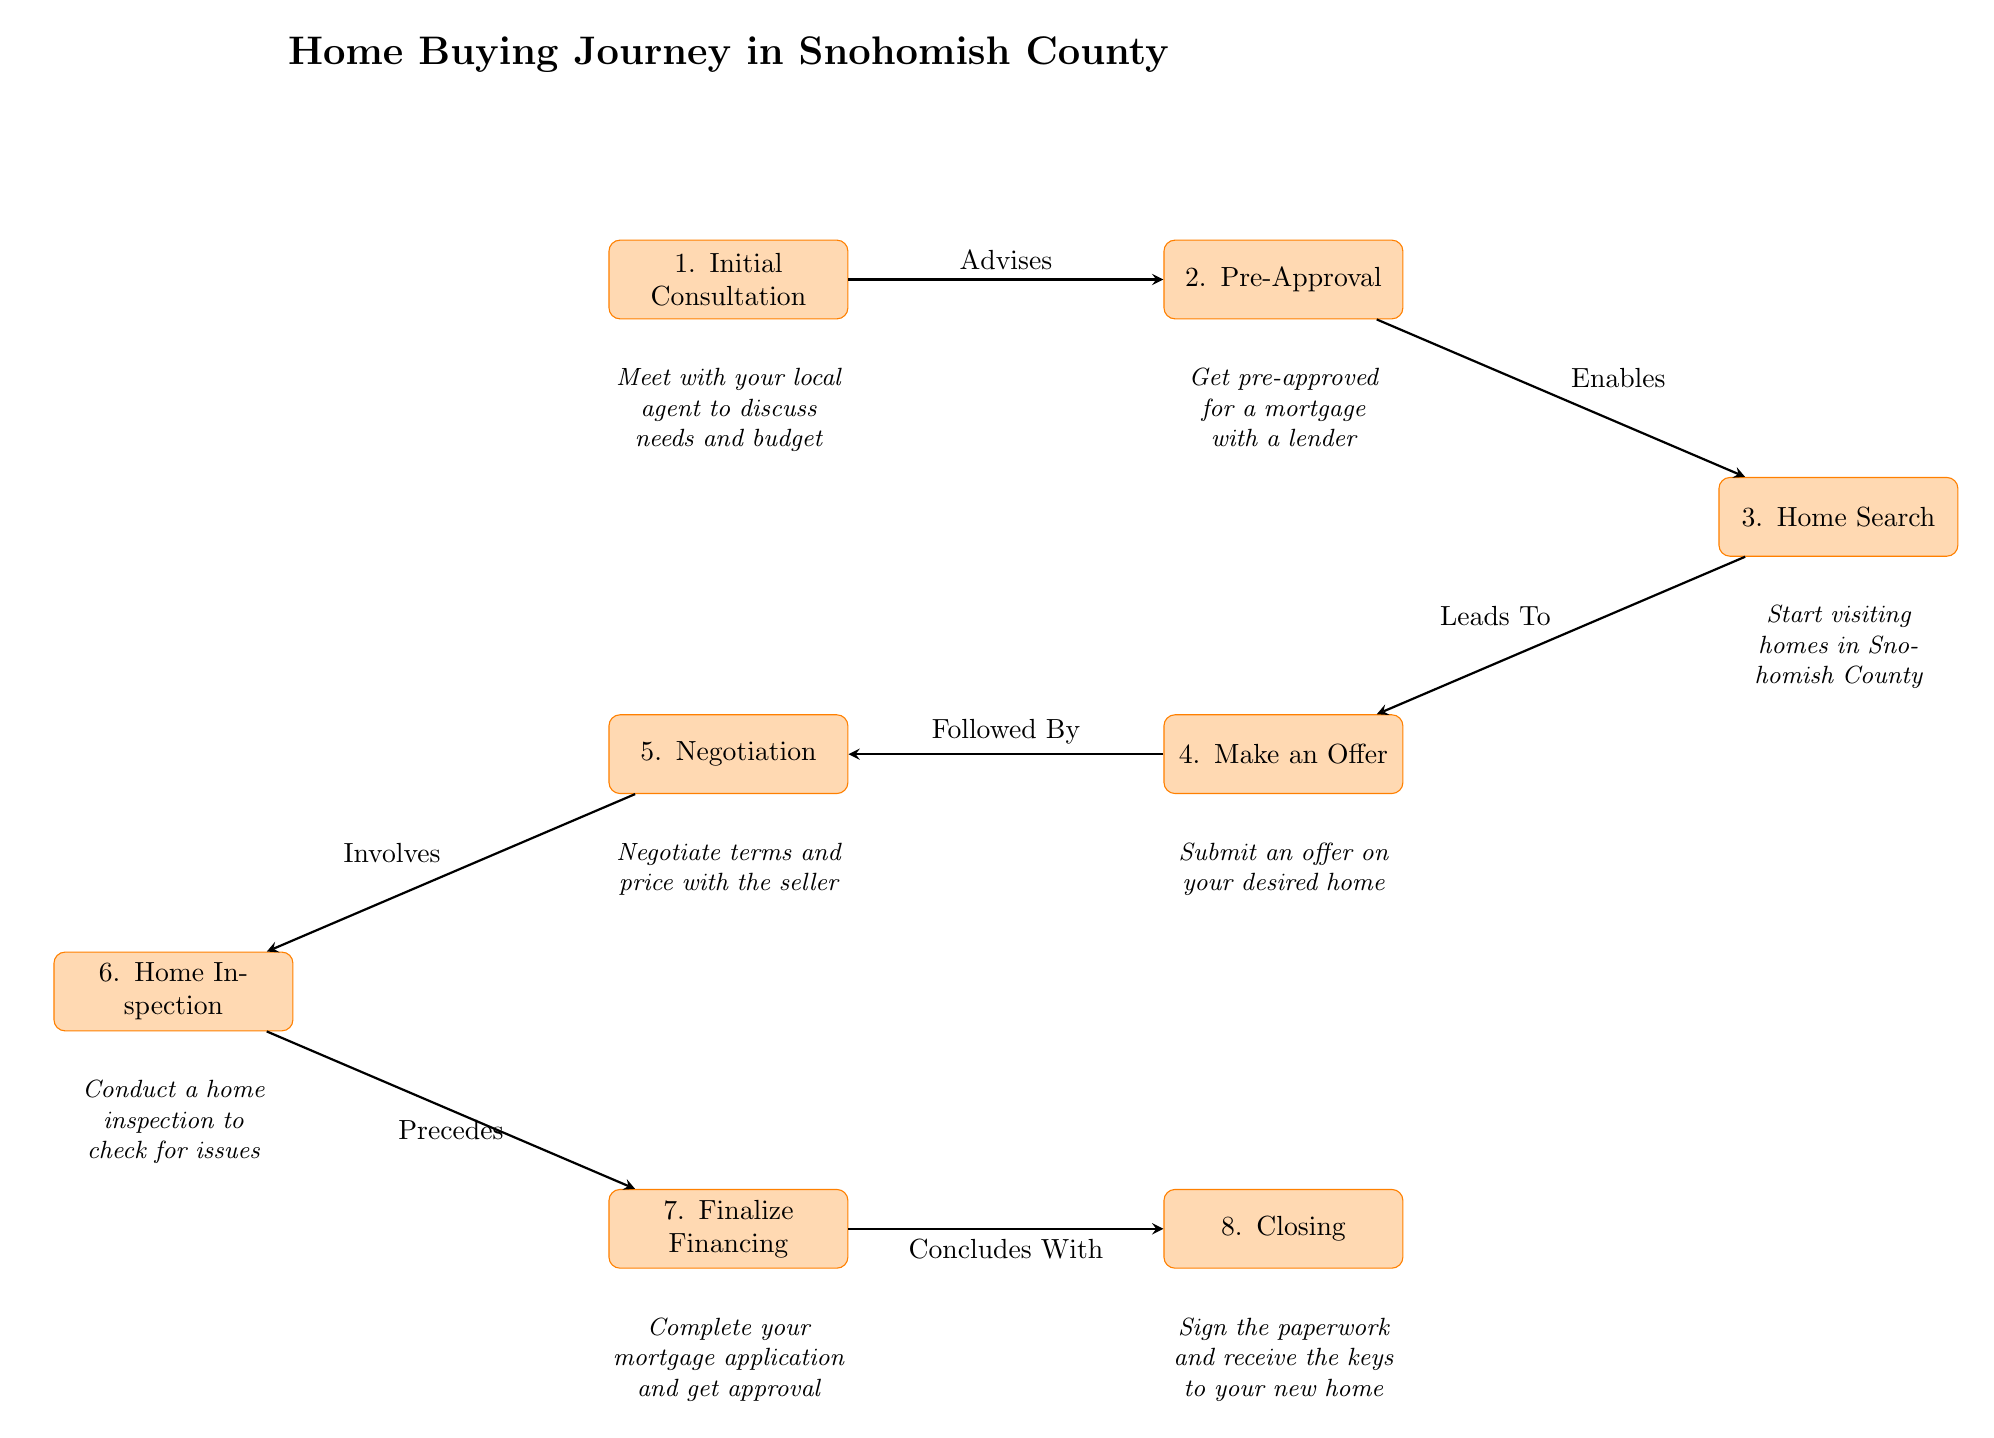What is the first step in the home buying journey? The first step in the journey is represented by the node labeled "1. Initial Consultation." It is the starting point before any other actions take place.
Answer: Initial Consultation How many total steps are in the home buying journey? The diagram shows a total of eight nodes, each representing a step in the process. By counting these nodes, we confirm there are eight steps.
Answer: 8 What action is taken after the 'Make an Offer' step? After the 'Make an Offer' step, the next step according to the diagram is the 'Negotiation' step, which follows it directly.
Answer: Negotiation What follows the 'Home Inspection' step? The 'Home Inspection' step is immediately followed by the 'Finalize Financing' step. This can be determined by looking at the directional arrows that indicate the flow of the process.
Answer: Finalize Financing What does the "Pre-Approval" step enable? The "Pre-Approval" step enables the "Home Search" step, as indicated by the arrow from "Pre-Approval" pointing to "Home Search," showing a direct relationship between them.
Answer: Home Search How does the 'Closing' step conclude the journey? The 'Closing' step concludes the journey as it is the final action in the process, where all paperwork is signed and the keys are received. This makes it the endpoint of the journey.
Answer: Closing Which step involves negotiating terms and price? The step that involves negotiating terms and price is specifically labeled as "5. Negotiation," which is positioned directly after the "Make an Offer" step in the sequence.
Answer: Negotiation What precedes the 'Finalize Financing' step? The 'Finalize Financing' step is preceded directly by the 'Home Inspection' step, as seen from the arrow leading into 'Finalize Financing' from 'Home Inspection.'
Answer: Home Inspection What relationship does the 'Initial Consultation' have with the 'Pre-Approval' step? The relationship is that the 'Initial Consultation' advises the 'Pre-Approval' step, as indicated by the arrow pointing from 'Initial Consultation' to 'Pre-Approval.' This means the consultation guides the next step of pre-approval.
Answer: Advises 